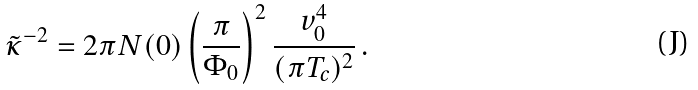<formula> <loc_0><loc_0><loc_500><loc_500>\tilde { \kappa } ^ { - 2 } = 2 \pi N ( 0 ) \left ( \frac { \pi } { \Phi _ { 0 } } \right ) ^ { 2 } \frac { v _ { 0 } ^ { 4 } } { ( \pi T _ { c } ) ^ { 2 } } \, .</formula> 